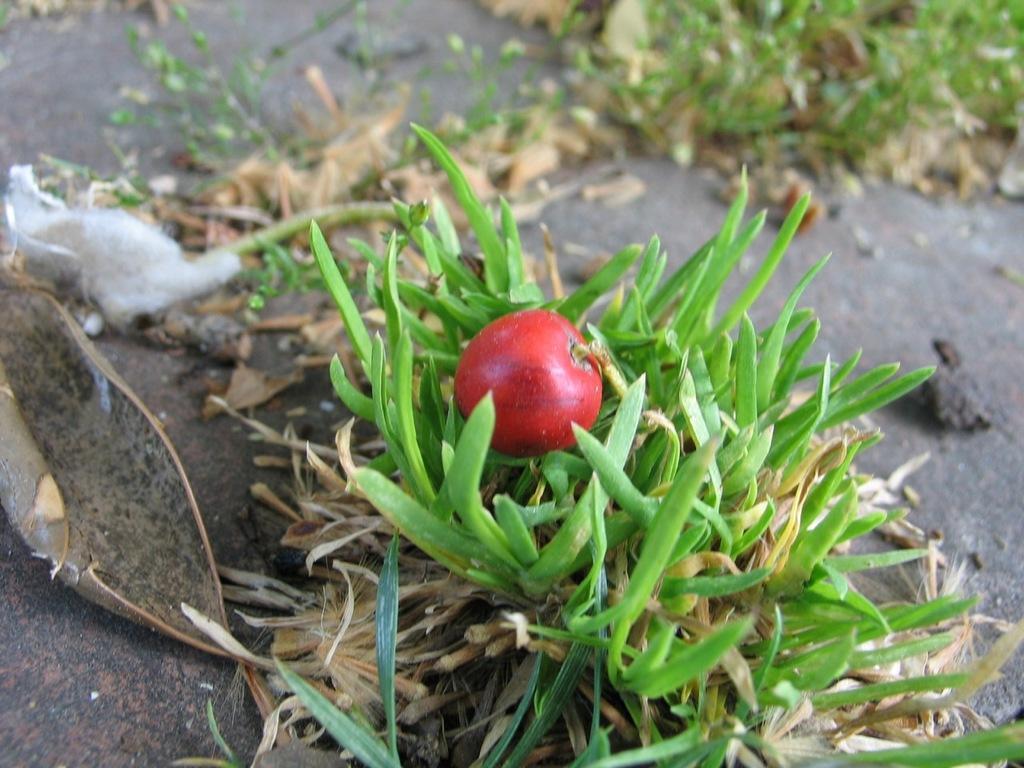Describe this image in one or two sentences. In this image I can see there is a plant with fruit. And there is a grass on the ground. And at the side there is a bark. 